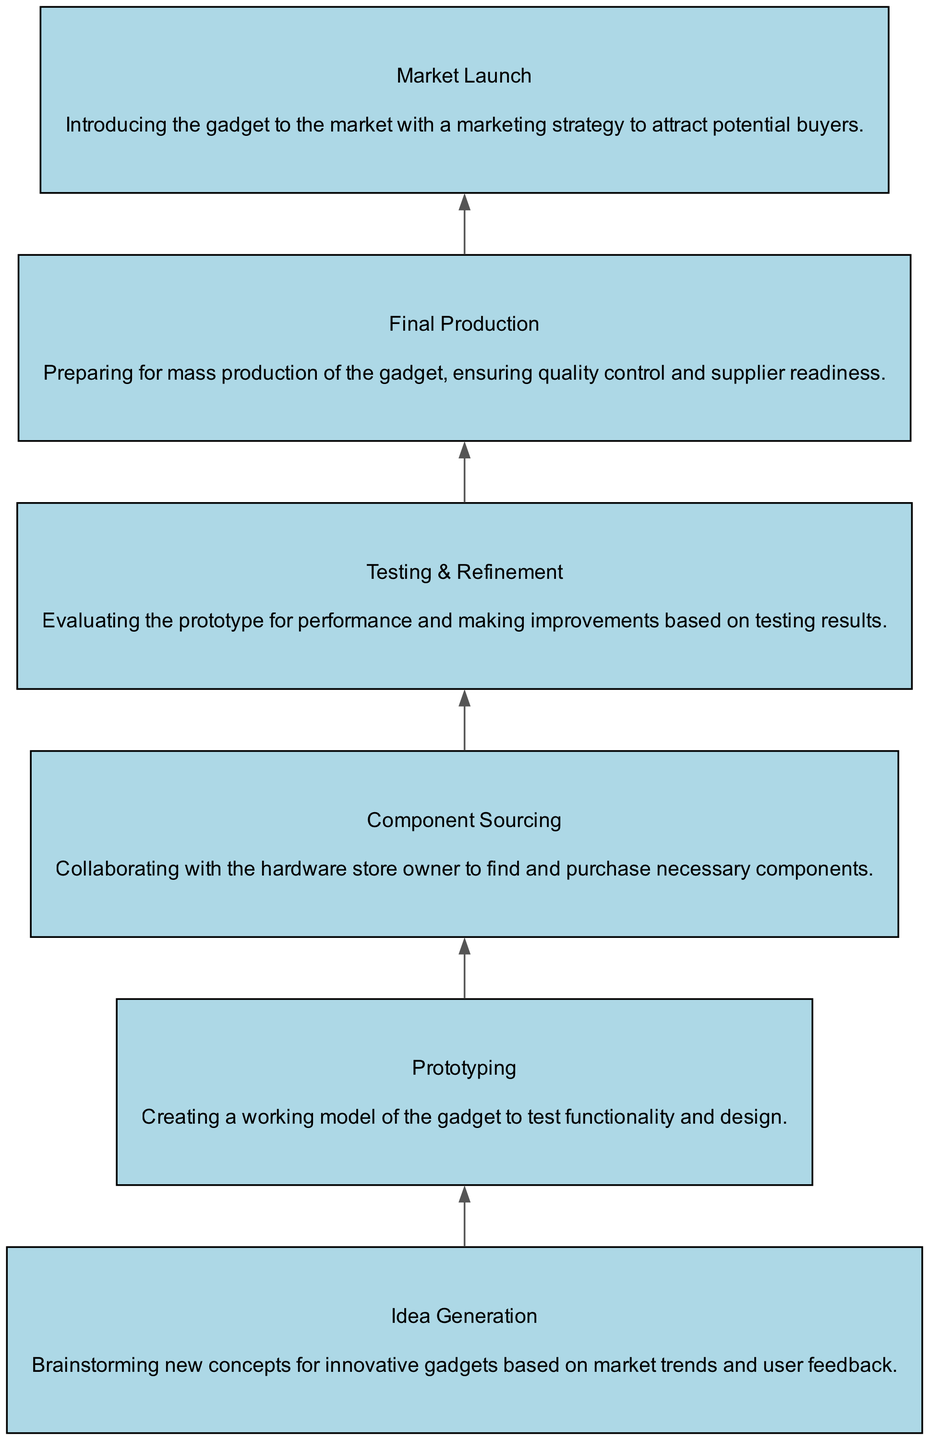What is the first stage in the product development process? The diagram displays the stages in a bottom-up manner, showing that the first stage is “Idea Generation.” This can be determined by looking at the topmost node of the flow chart.
Answer: Idea Generation How many total stages are shown in the diagram? By counting each unique stage listed in the diagram, we identify six distinct stages: Idea Generation, Prototyping, Component Sourcing, Testing & Refinement, Final Production, and Market Launch.
Answer: Six Which stage comes after Testing & Refinement? The diagram illustrates a sequential flow of stages, and after Testing & Refinement, the next stage listed is Final Production. This is determined by following the directed edges from the Testing & Refinement node.
Answer: Final Production What is the main focus of the Component Sourcing stage? The description associated with the Component Sourcing node clearly indicates that this stage focuses on “Collaborating with the hardware store owner to find and purchase necessary components.” This information is provided directly under the Component Sourcing label in the diagram.
Answer: Collaborating with the hardware store owner Which two stages are directly connected by an edge? Analyzing the diagram reveals that several stages are connected. One example is the direct connection from Prototyping to Component Sourcing, as noted by the arrow suggesting a direct transition in the development process from one stage to the next.
Answer: Prototyping and Component Sourcing In what phase is the prototype evaluated for performance? The Testing & Refinement stage specifically highlights that this phase involves “Evaluating the prototype for performance and making improvements.” This indicates that it focuses on testing the gadget's functionality and making necessary adjustments.
Answer: Testing & Refinement 